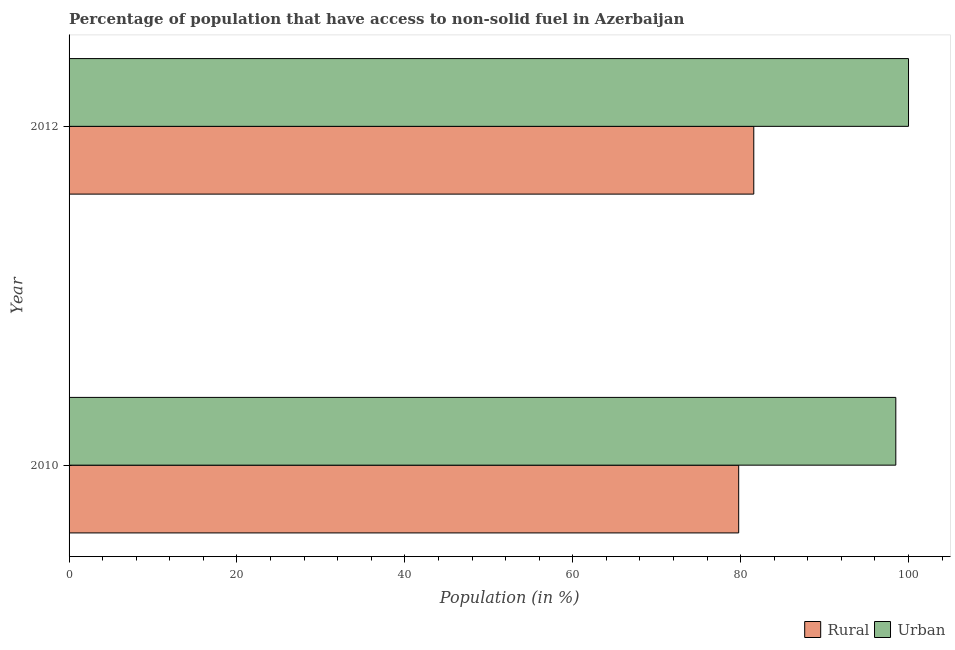How many different coloured bars are there?
Your answer should be compact. 2. How many groups of bars are there?
Ensure brevity in your answer.  2. Are the number of bars on each tick of the Y-axis equal?
Provide a short and direct response. Yes. How many bars are there on the 2nd tick from the top?
Keep it short and to the point. 2. How many bars are there on the 2nd tick from the bottom?
Your answer should be compact. 2. What is the label of the 1st group of bars from the top?
Provide a succinct answer. 2012. What is the urban population in 2010?
Provide a short and direct response. 98.49. Across all years, what is the maximum rural population?
Give a very brief answer. 81.57. Across all years, what is the minimum urban population?
Your answer should be compact. 98.49. In which year was the urban population maximum?
Your response must be concise. 2012. What is the total rural population in the graph?
Provide a short and direct response. 161.34. What is the difference between the urban population in 2010 and that in 2012?
Give a very brief answer. -1.51. What is the difference between the rural population in 2010 and the urban population in 2012?
Offer a terse response. -20.23. What is the average urban population per year?
Ensure brevity in your answer.  99.24. In the year 2012, what is the difference between the urban population and rural population?
Offer a terse response. 18.43. What is the ratio of the rural population in 2010 to that in 2012?
Ensure brevity in your answer.  0.98. Is the difference between the urban population in 2010 and 2012 greater than the difference between the rural population in 2010 and 2012?
Ensure brevity in your answer.  Yes. In how many years, is the rural population greater than the average rural population taken over all years?
Keep it short and to the point. 1. What does the 1st bar from the top in 2010 represents?
Your answer should be compact. Urban. What does the 1st bar from the bottom in 2010 represents?
Give a very brief answer. Rural. How many bars are there?
Keep it short and to the point. 4. How many years are there in the graph?
Offer a very short reply. 2. What is the difference between two consecutive major ticks on the X-axis?
Provide a succinct answer. 20. Does the graph contain grids?
Make the answer very short. No. How many legend labels are there?
Your answer should be very brief. 2. How are the legend labels stacked?
Keep it short and to the point. Horizontal. What is the title of the graph?
Your response must be concise. Percentage of population that have access to non-solid fuel in Azerbaijan. Does "US$" appear as one of the legend labels in the graph?
Your answer should be compact. No. What is the Population (in %) in Rural in 2010?
Provide a succinct answer. 79.77. What is the Population (in %) in Urban in 2010?
Ensure brevity in your answer.  98.49. What is the Population (in %) in Rural in 2012?
Keep it short and to the point. 81.57. Across all years, what is the maximum Population (in %) in Rural?
Provide a short and direct response. 81.57. Across all years, what is the maximum Population (in %) in Urban?
Offer a terse response. 100. Across all years, what is the minimum Population (in %) in Rural?
Offer a very short reply. 79.77. Across all years, what is the minimum Population (in %) in Urban?
Provide a short and direct response. 98.49. What is the total Population (in %) of Rural in the graph?
Offer a very short reply. 161.34. What is the total Population (in %) in Urban in the graph?
Offer a terse response. 198.49. What is the difference between the Population (in %) of Rural in 2010 and that in 2012?
Your answer should be compact. -1.8. What is the difference between the Population (in %) of Urban in 2010 and that in 2012?
Provide a short and direct response. -1.51. What is the difference between the Population (in %) of Rural in 2010 and the Population (in %) of Urban in 2012?
Offer a terse response. -20.23. What is the average Population (in %) in Rural per year?
Your response must be concise. 80.67. What is the average Population (in %) in Urban per year?
Your answer should be very brief. 99.24. In the year 2010, what is the difference between the Population (in %) of Rural and Population (in %) of Urban?
Provide a succinct answer. -18.72. In the year 2012, what is the difference between the Population (in %) of Rural and Population (in %) of Urban?
Give a very brief answer. -18.43. What is the ratio of the Population (in %) in Urban in 2010 to that in 2012?
Ensure brevity in your answer.  0.98. What is the difference between the highest and the second highest Population (in %) in Rural?
Provide a short and direct response. 1.8. What is the difference between the highest and the second highest Population (in %) in Urban?
Your answer should be very brief. 1.51. What is the difference between the highest and the lowest Population (in %) in Rural?
Provide a succinct answer. 1.8. What is the difference between the highest and the lowest Population (in %) of Urban?
Give a very brief answer. 1.51. 